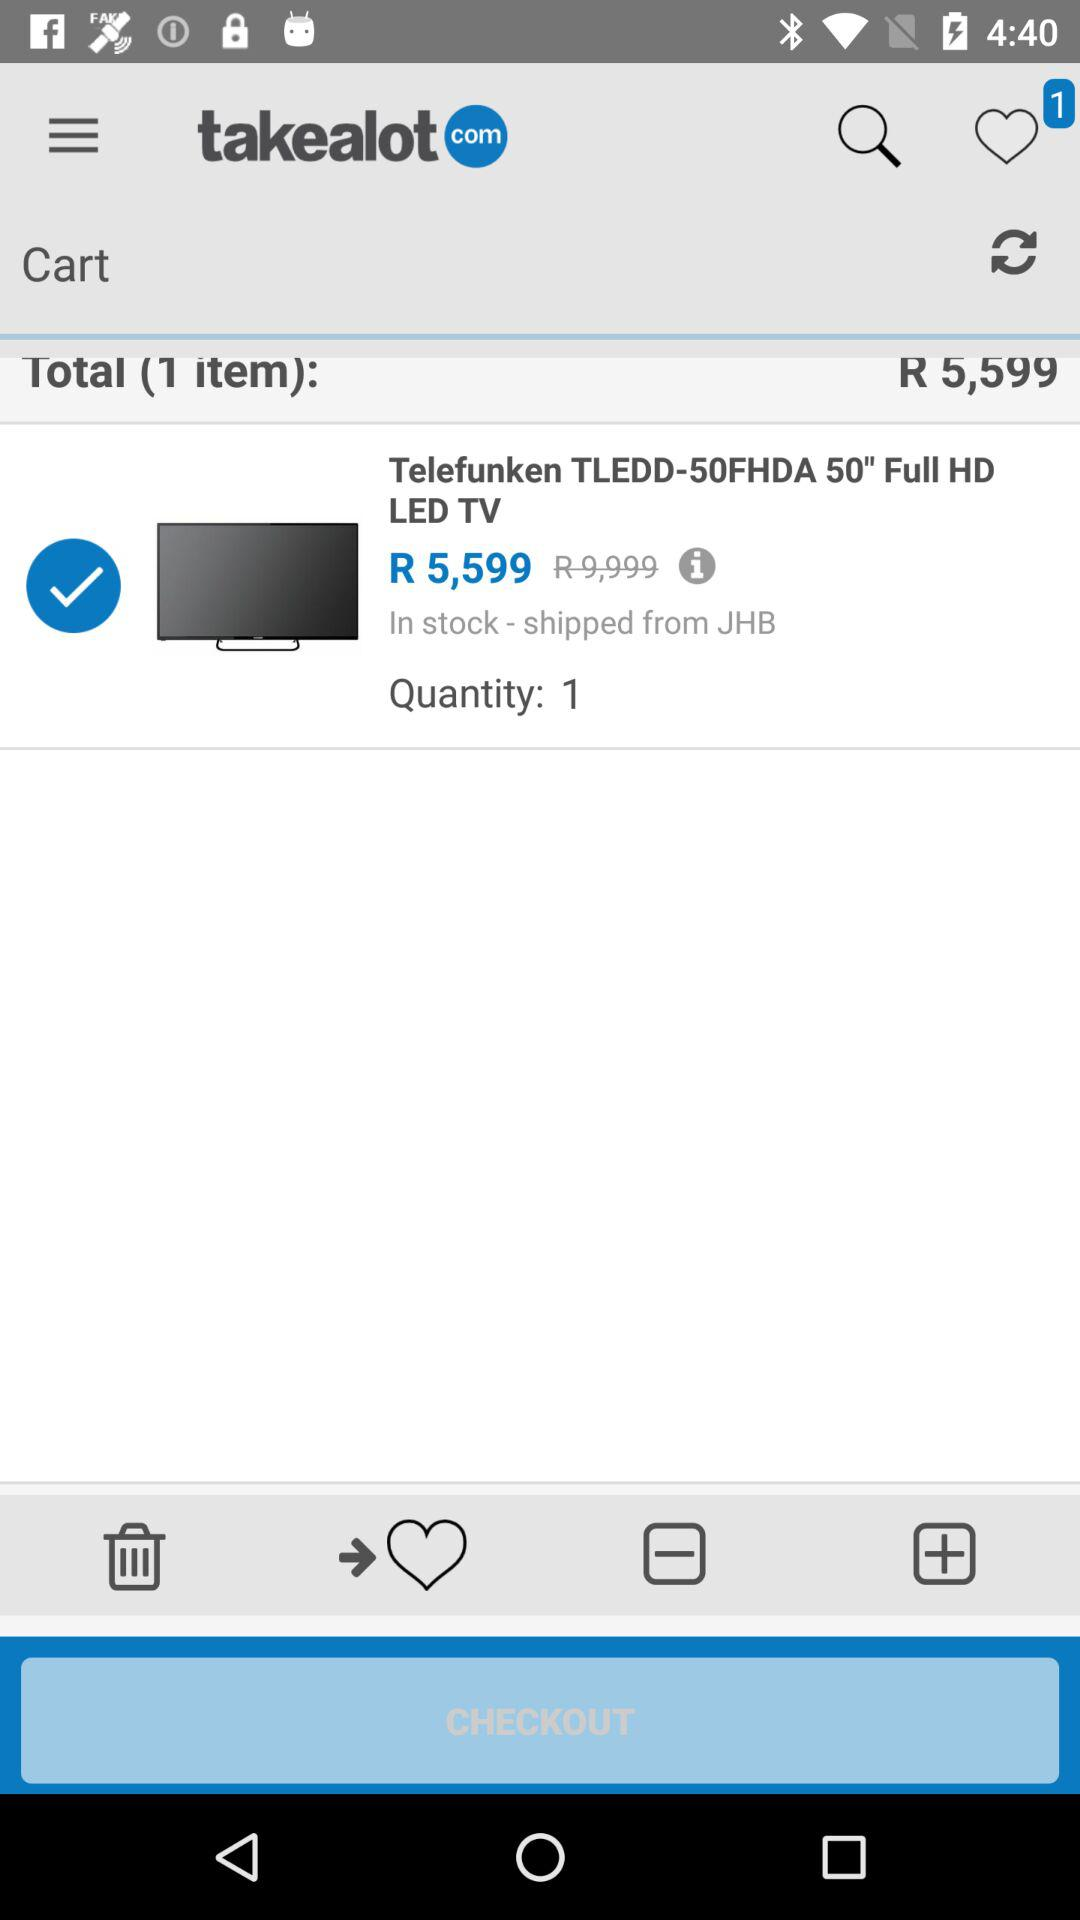Where was the product shipped from? The product was shipped from JHB. 